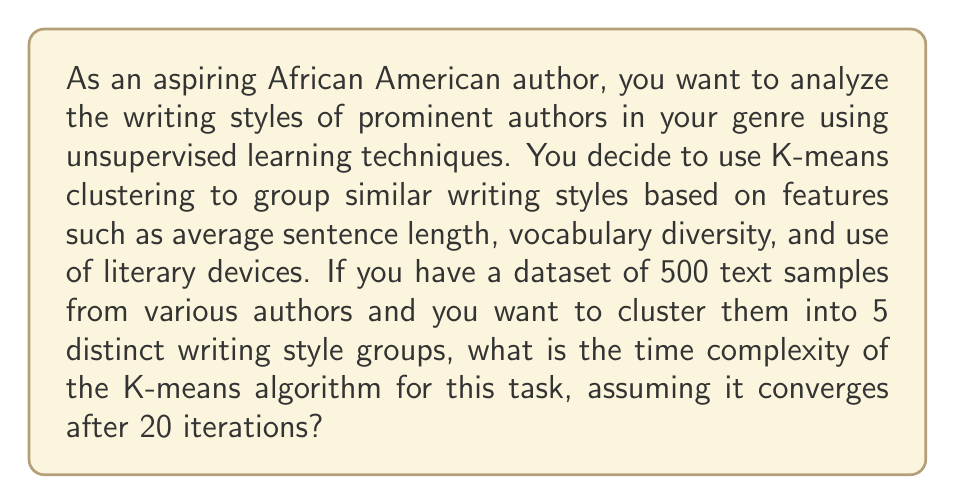Help me with this question. To determine the time complexity of the K-means algorithm for this scenario, we need to consider the following factors:

1. Number of samples: $n = 500$
2. Number of clusters: $k = 5$
3. Number of features: $d = 3$ (average sentence length, vocabulary diversity, use of literary devices)
4. Number of iterations: $i = 20$

The K-means algorithm consists of two main steps that are repeated for each iteration:

1. Assigning each sample to the nearest centroid
2. Updating the centroids

Step 1: Assigning samples to centroids
- For each sample, we calculate the distance to each of the $k$ centroids.
- This requires $O(k \cdot d)$ operations per sample.
- We do this for all $n$ samples.
- Total complexity for this step: $O(n \cdot k \cdot d)$

Step 2: Updating centroids
- We recalculate the mean of all samples assigned to each centroid.
- This requires $O(n \cdot d)$ operations in total.

We perform these steps for $i$ iterations.

Therefore, the total time complexity is:

$$O(i \cdot (n \cdot k \cdot d + n \cdot d))$$

Simplifying:
$$O(i \cdot n \cdot d \cdot (k + 1))$$

Given that $k$ is typically much smaller than $n$, we can further simplify this to:

$$O(i \cdot n \cdot d \cdot k)$$

Substituting the values from our scenario:

$$O(20 \cdot 500 \cdot 3 \cdot 5) = O(150,000)$$

This represents the order of magnitude of the number of operations required for the K-means algorithm in this specific case.
Answer: $O(i \cdot n \cdot d \cdot k) = O(20 \cdot 500 \cdot 3 \cdot 5) = O(150,000)$ 